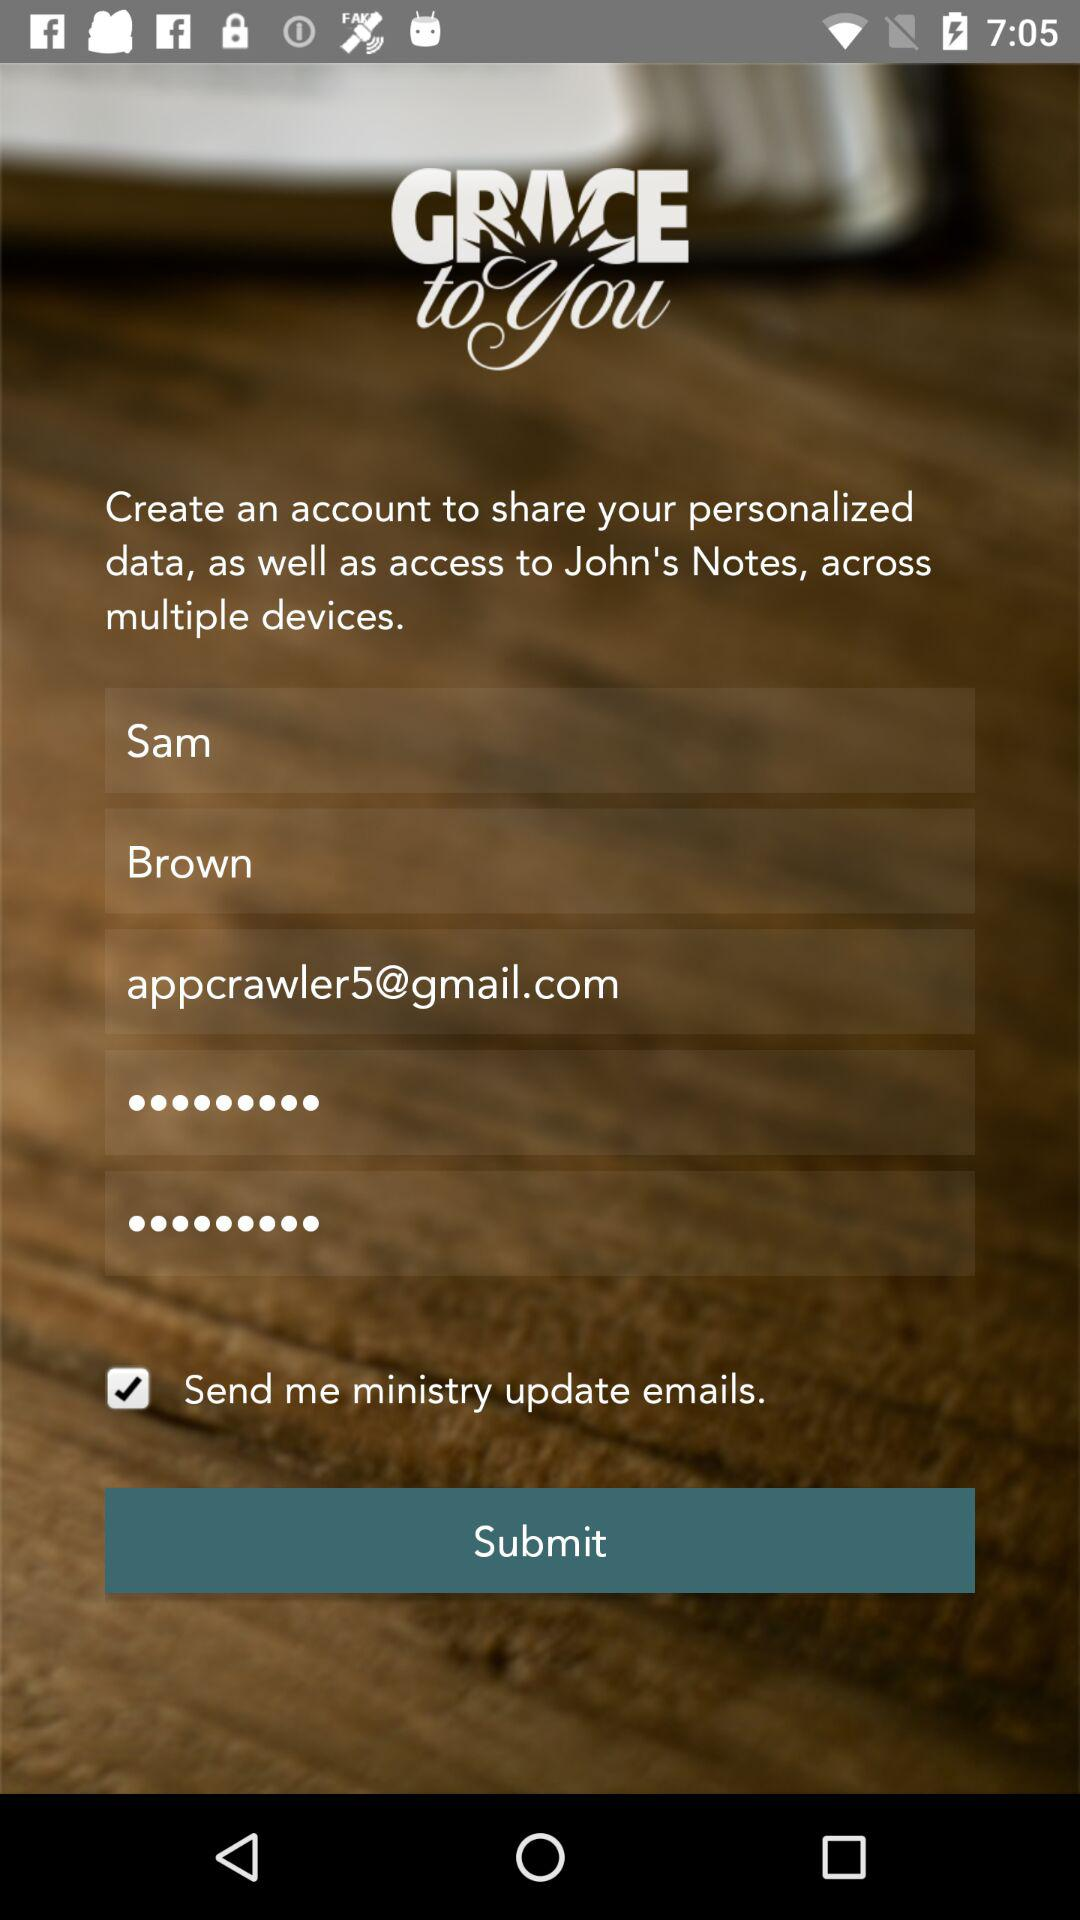What is the status of "Send me ministry update emails."? The status is "on". 